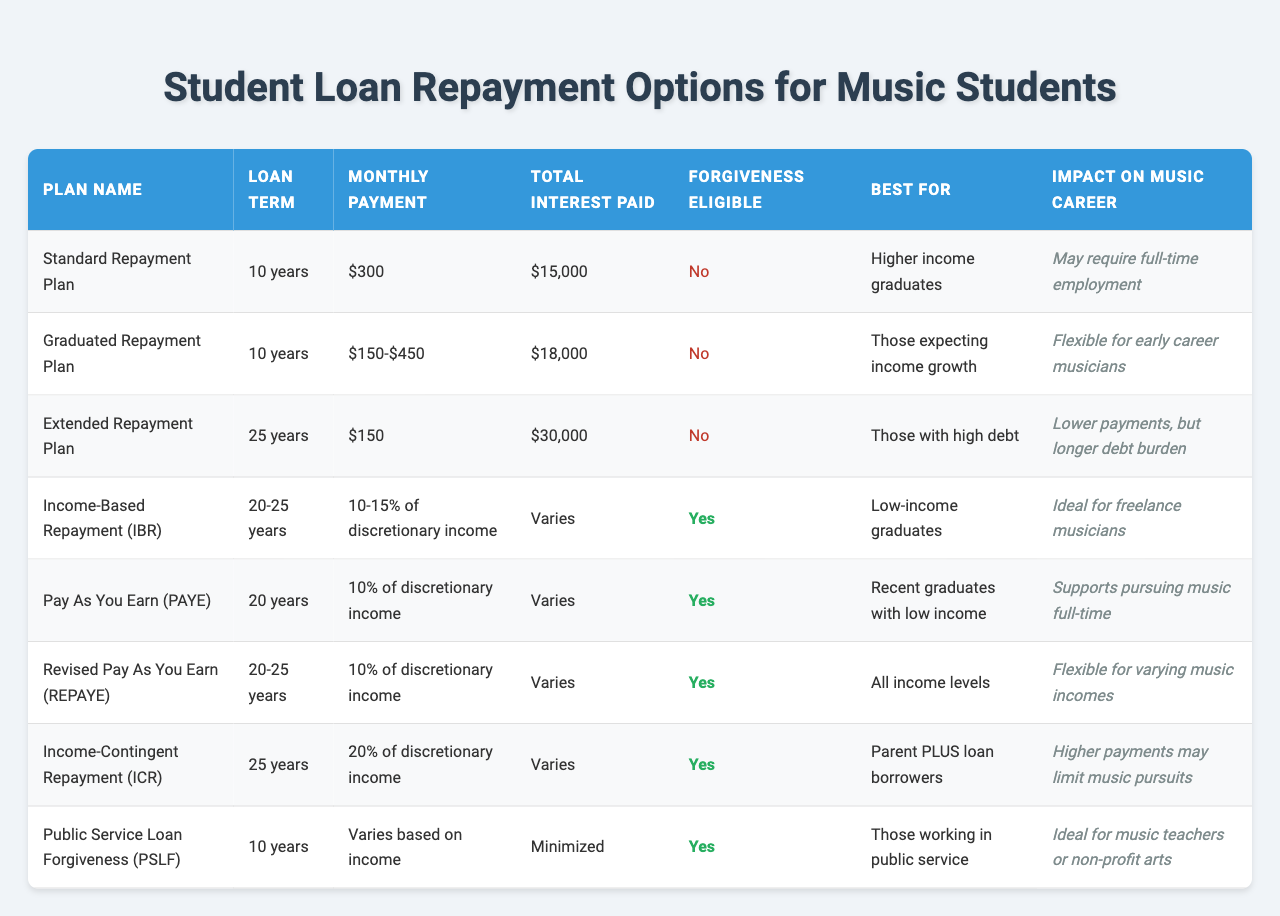What is the monthly payment for the Standard Repayment Plan? The table lists the monthly payment for the Standard Repayment Plan as $300.
Answer: $300 Which repayment plan has the longest loan term? The Extended Repayment Plan has a loan term of 25 years, which is the longest in the table.
Answer: Extended Repayment Plan Is the Graduated Repayment Plan eligible for forgiveness? The table states that the Graduated Repayment Plan is not eligible for forgiveness.
Answer: No Which repayment plans are best for low-income graduates? The table indicates that Income-Based Repayment (IBR), Pay As You Earn (PAYE), and Revised Pay As You Earn (REPAYE) are best for low-income graduates.
Answer: IBR, PAYE, REPAYE What is the total interest paid for the Extended Repayment Plan? According to the table, the total interest paid for the Extended Repayment Plan is $30,000.
Answer: $30,000 What percentage of discretionary income is required for the Income-Contingent Repayment (ICR) plan? The Income-Contingent Repayment (ICR) plan requires 20% of discretionary income.
Answer: 20% Which repayment plan is ideal for freelance musicians? The Income-Based Repayment (IBR) is identified as ideal for freelance musicians in the table.
Answer: Income-Based Repayment (IBR) If a student chooses the PAYE plan over the Standard Repayment Plan, how much less will they potentially pay monthly based on income? The PAYE plan's monthly payment is 10% of discretionary income and varies, while the Standard Repayment Plan has a fixed payment of $300. Since PAYE can be lower based on income, an individual may pay significantly less, although exact figures are variable.
Answer: Varies based on income What impact does the Extended Repayment Plan have on a music career? The impact of the Extended Repayment Plan on a music career is noted as "Lower payments, but longer debt burden".
Answer: Lower payments, longer debt burden Compare the total interest paid between Standard and Graduated Repayment Plans. The total interest paid for the Standard Repayment Plan is $15,000, while the Graduated Repayment Plan has $18,000. The difference is $3,000 more for the Graduated Repayment Plan.
Answer: $3,000 more for Graduated Plan Which plans are suitable for higher income graduates? The table shows that only the Standard Repayment Plan is specifically best for higher income graduates.
Answer: Standard Repayment Plan How do the monthly payments of the PAYE and REPAYE plans compare? Both PAYE and REPAYE plans require 10% of discretionary income for their monthly payments, meaning they are equivalent regarding payment structure, but the actual amounts depend on discretionary income, which can vary.
Answer: Equivalent, depends on income 